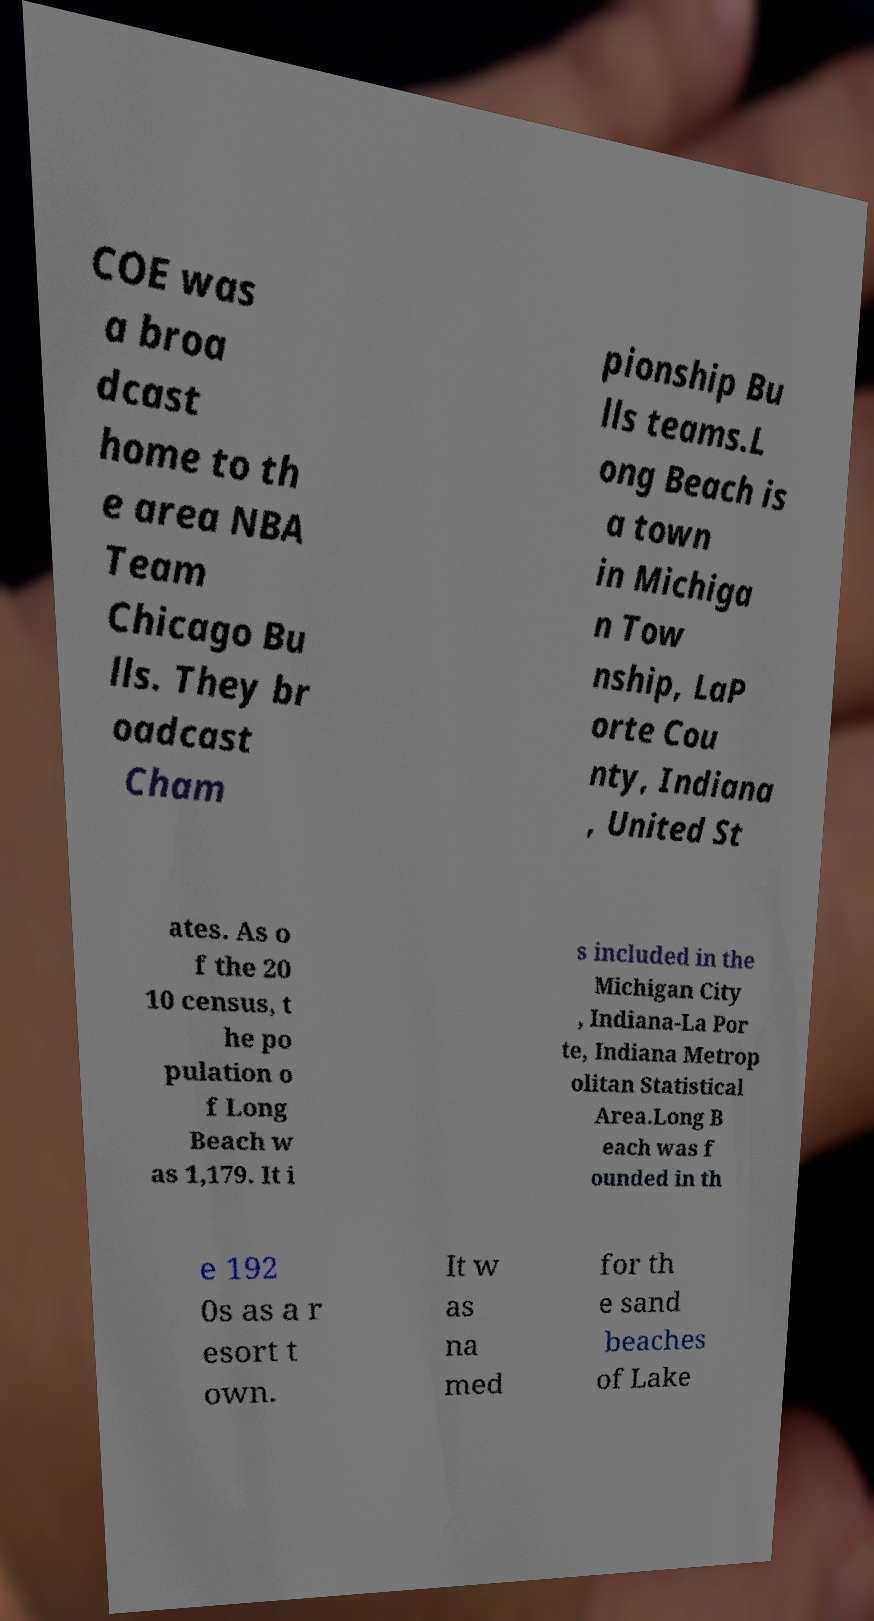Could you assist in decoding the text presented in this image and type it out clearly? COE was a broa dcast home to th e area NBA Team Chicago Bu lls. They br oadcast Cham pionship Bu lls teams.L ong Beach is a town in Michiga n Tow nship, LaP orte Cou nty, Indiana , United St ates. As o f the 20 10 census, t he po pulation o f Long Beach w as 1,179. It i s included in the Michigan City , Indiana-La Por te, Indiana Metrop olitan Statistical Area.Long B each was f ounded in th e 192 0s as a r esort t own. It w as na med for th e sand beaches of Lake 